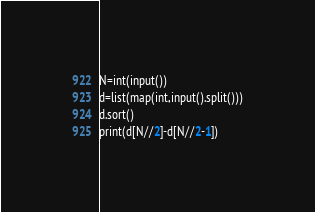<code> <loc_0><loc_0><loc_500><loc_500><_Python_>N=int(input())
d=list(map(int,input().split()))
d.sort()
print(d[N//2]-d[N//2-1])
</code> 